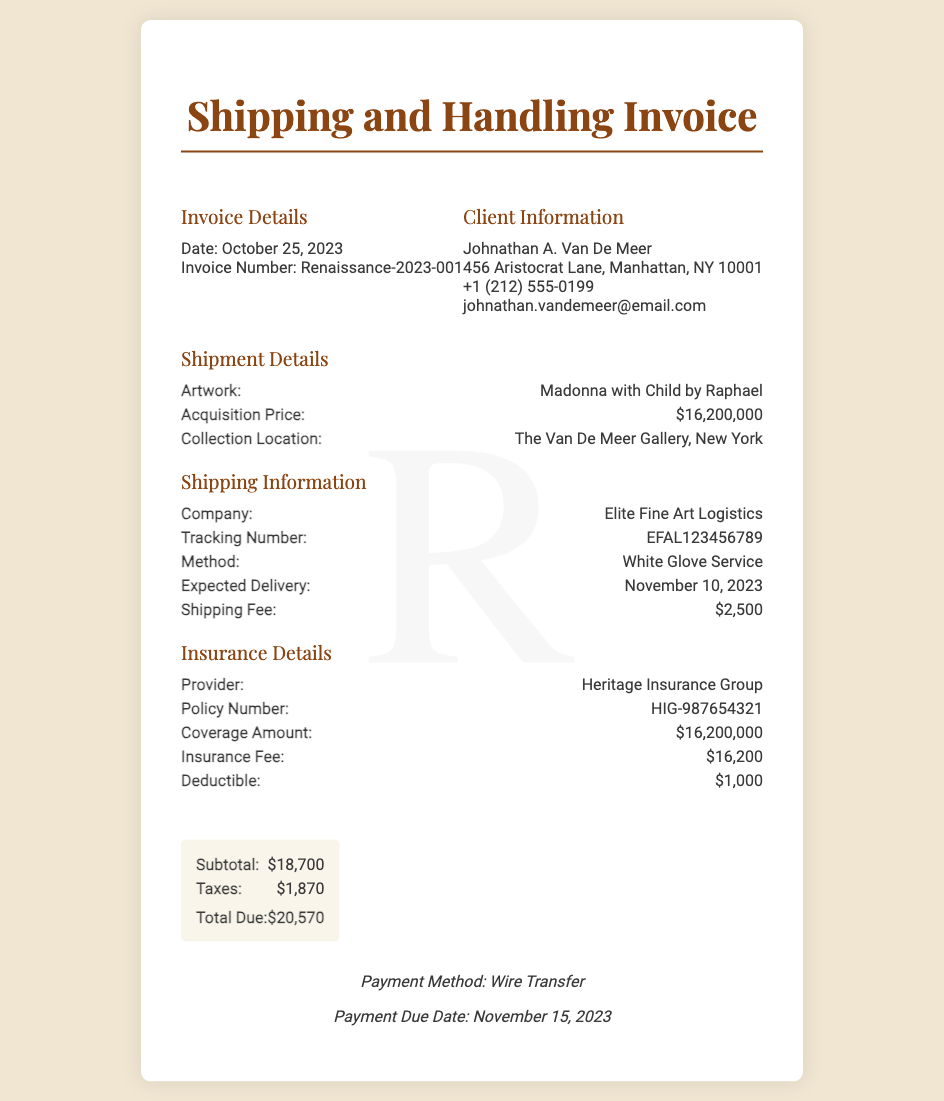What is the artwork title? The title of the artwork is provided in the shipment details section of the document.
Answer: Madonna with Child by Raphael What is the acquisition price? The acquisition price of the artwork is clearly stated in the document.
Answer: $16,200,000 Who is the shipping company? The name of the shipping company is mentioned under the shipping information section.
Answer: Elite Fine Art Logistics What is the expected delivery date? The expected delivery date is listed in the shipping information section of the document.
Answer: November 10, 2023 What is the total due amount? The total due amount is found in the total section at the bottom of the invoice.
Answer: $20,570 What is the insurance fee? The insurance fee is specifically stated in the insurance details section of the document.
Answer: $16,200 What is the deductible amount? The deductible amount is provided in the insurance details section of the document.
Answer: $1,000 What is the payment due date? The payment due date is indicated in the payment terms at the bottom of the document.
Answer: November 15, 2023 How much is the shipping fee? The shipping fee can be found in the shipping information section of the invoice.
Answer: $2,500 